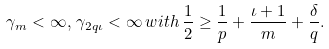<formula> <loc_0><loc_0><loc_500><loc_500>\gamma _ { m } < \infty , \, \gamma _ { 2 q \iota } < \infty \, w i t h \, \frac { 1 } { 2 } \geq \frac { 1 } { p } + \frac { \iota + 1 } { m } + \frac { \delta } { q } .</formula> 